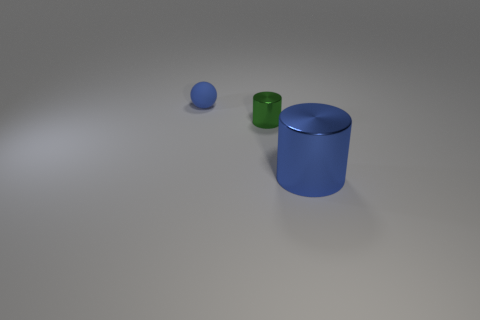What is the color of the small rubber object?
Offer a very short reply. Blue. There is a small object that is the same material as the large object; what is its color?
Your answer should be very brief. Green. What number of other large blue objects have the same material as the big blue thing?
Provide a short and direct response. 0. There is a tiny green object; how many rubber balls are behind it?
Make the answer very short. 1. Is the blue thing that is on the right side of the tiny blue matte thing made of the same material as the cylinder on the left side of the big blue metal thing?
Your answer should be very brief. Yes. Are there more green objects that are left of the small green cylinder than large cylinders that are left of the blue rubber sphere?
Offer a terse response. No. What material is the object that is the same color as the small sphere?
Offer a very short reply. Metal. Is there any other thing that has the same shape as the tiny blue rubber thing?
Provide a succinct answer. No. There is a object that is behind the large shiny cylinder and in front of the tiny ball; what is its material?
Offer a terse response. Metal. Is the material of the blue sphere the same as the cylinder that is behind the large blue metallic object?
Give a very brief answer. No. 